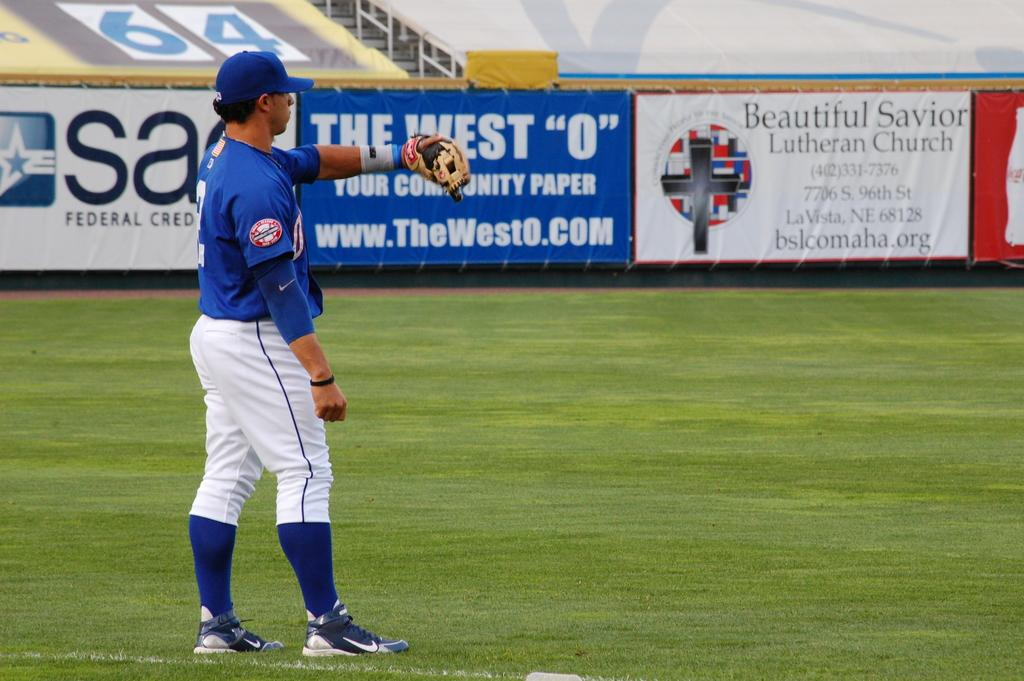<image>
Summarize the visual content of the image. a baseball player on a field with banners for a lutheren church of fence 